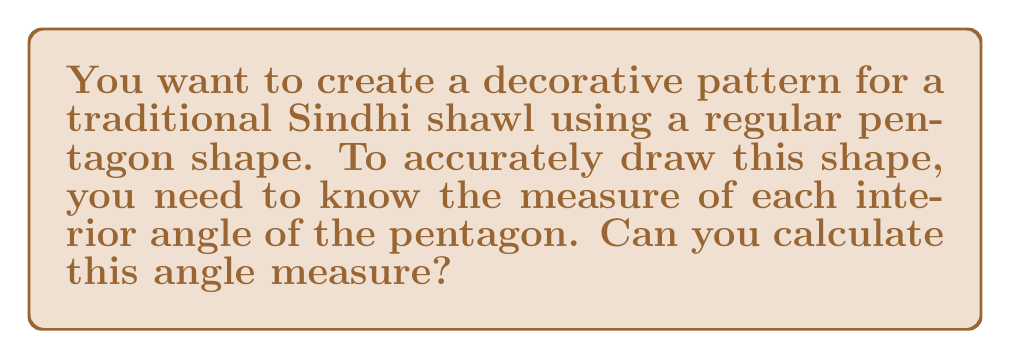Teach me how to tackle this problem. Let's approach this step-by-step:

1) First, recall the formula for the sum of interior angles of any polygon with $n$ sides:

   $S = (n-2) \times 180°$

2) For a pentagon, $n = 5$. Let's substitute this into our formula:

   $S = (5-2) \times 180° = 3 \times 180° = 540°$

3) Now, we know that the sum of all interior angles in a pentagon is 540°.

4) In a regular pentagon, all interior angles are equal. Let's call each angle $x°$.

5) Since there are 5 angles, and they all add up to 540°, we can write:

   $5x = 540°$

6) To find $x$, we divide both sides by 5:

   $x = 540° \div 5 = 108°$

Therefore, each interior angle of a regular pentagon measures 108°.
Answer: 108° 